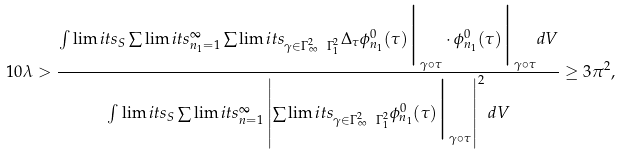<formula> <loc_0><loc_0><loc_500><loc_500>1 0 \lambda > \frac { \int \lim i t s _ { S } \sum \lim i t s ^ { \infty } _ { n _ { 1 } = 1 } \sum \lim i t s _ { \gamma \in \Gamma ^ { 2 } _ { \infty } \ \Gamma ^ { 2 } _ { 1 } } { \Delta } _ { \tau } \phi ^ { 0 } _ { n _ { 1 } } ( \tau ) \Big | _ { \gamma \circ \tau } \cdot \phi ^ { 0 } _ { n _ { 1 } } ( \tau ) \Big | _ { \gamma \circ \tau } d V } { \int \lim i t s _ { S } \sum \lim i t s ^ { \infty } _ { n = 1 } \left | \sum \lim i t s _ { \gamma \in \Gamma ^ { 2 } _ { \infty } \ \Gamma ^ { 2 } _ { 1 } } \phi ^ { 0 } _ { n _ { 1 } } ( \tau ) \Big | _ { \gamma \circ \tau } \right | ^ { 2 } d V } \geq 3 \pi ^ { 2 } ,</formula> 